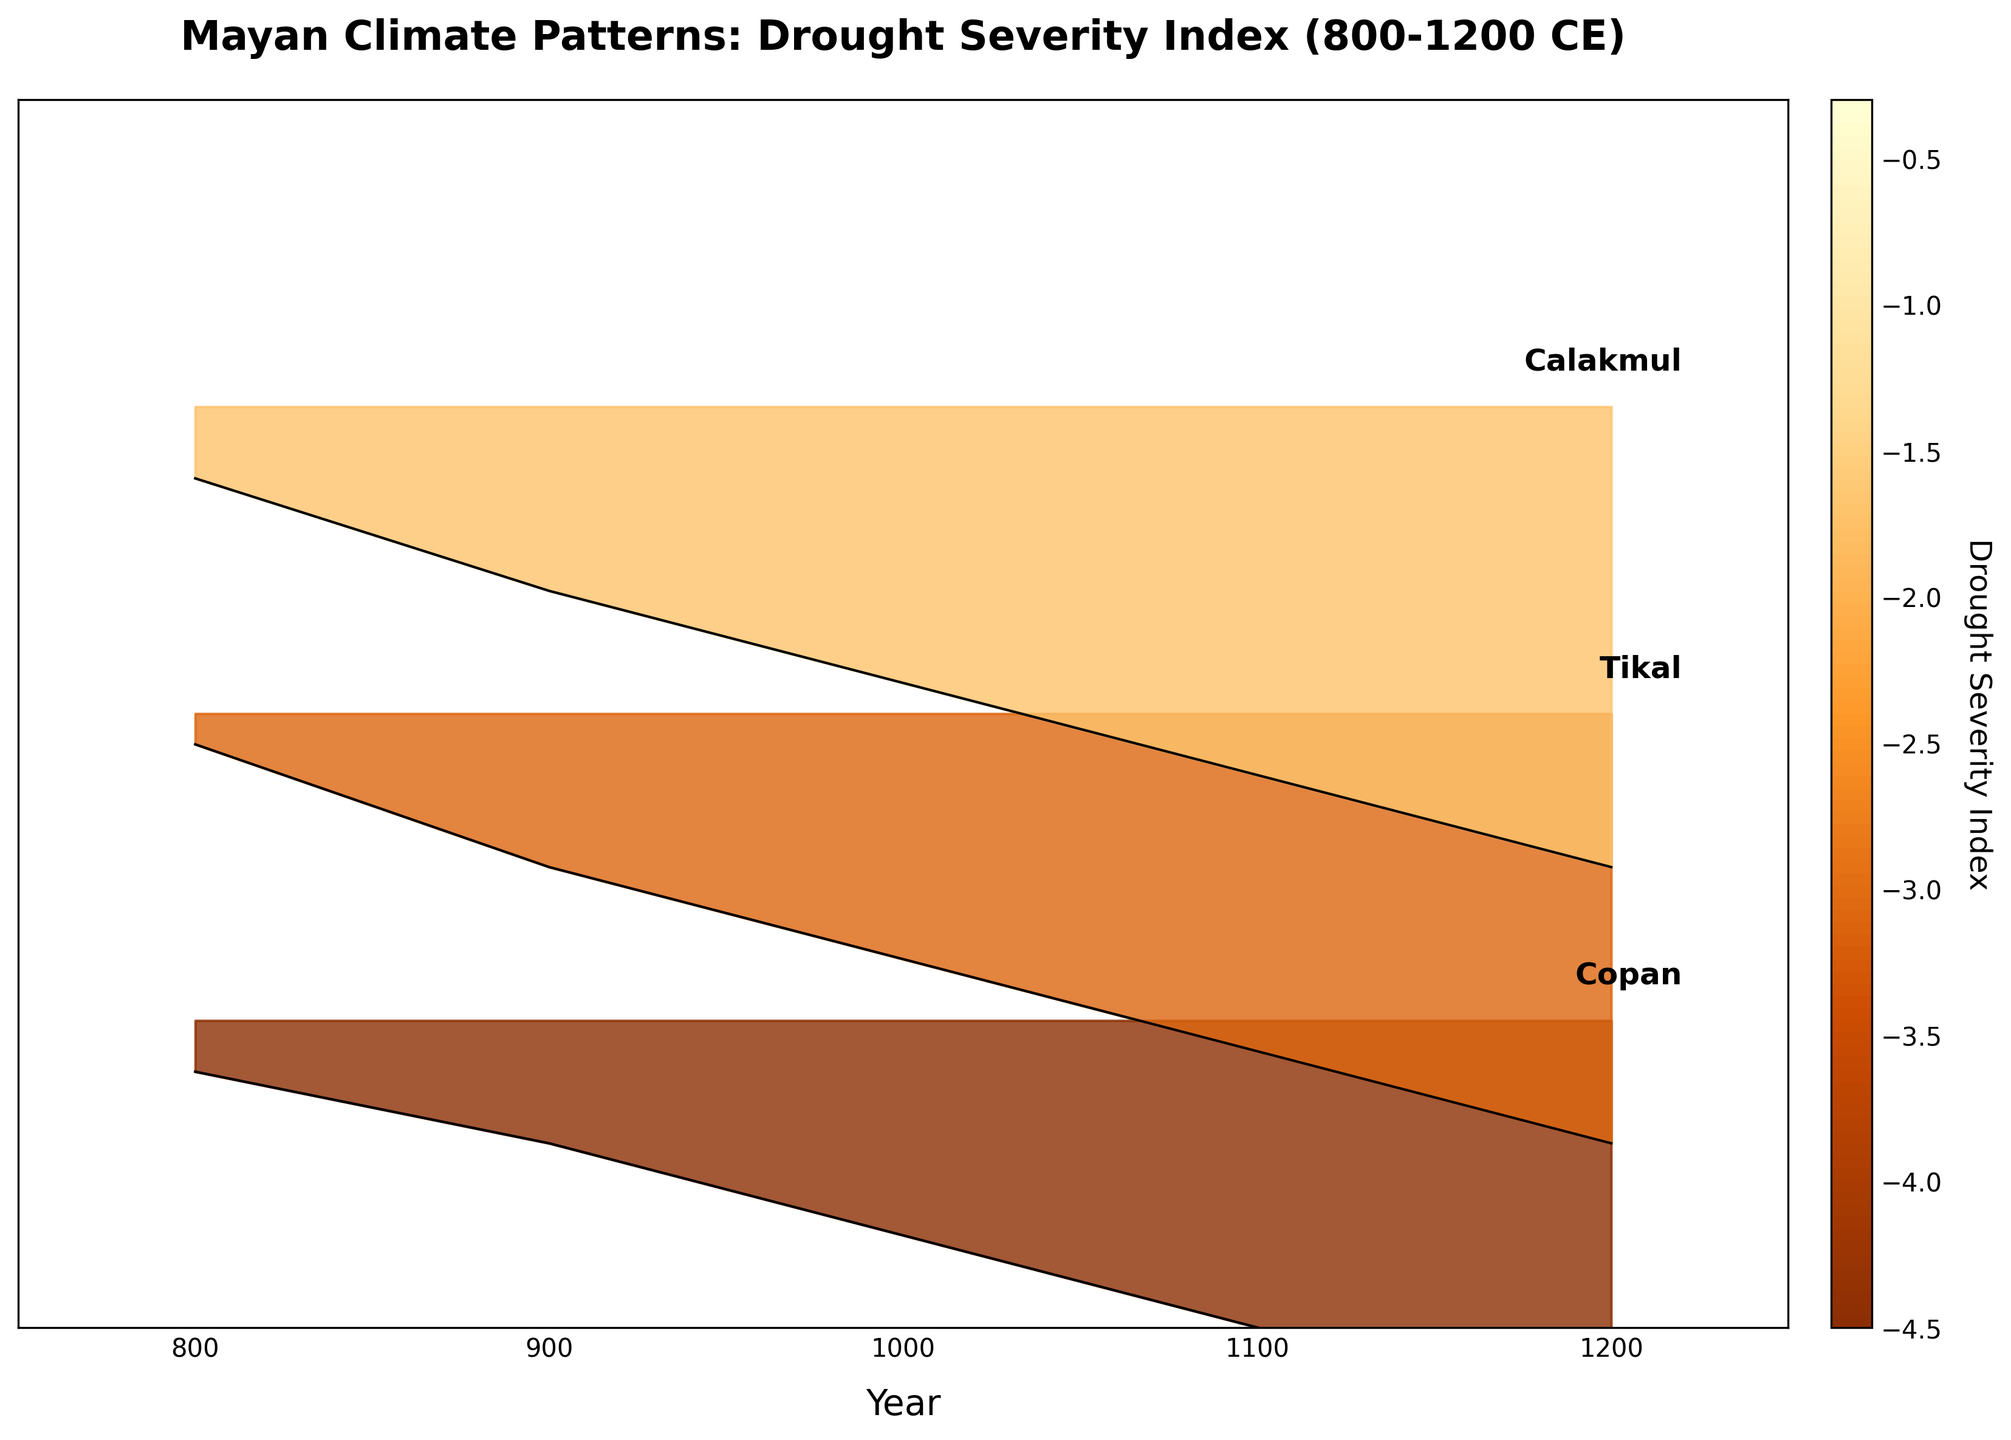What period is covered in the title of the plot? The title of the plot specifies the years 800-1200 CE
Answer: 800-1200 CE How many regions are represented in the plot? The figure labels three regions on the right side of the plot: Copan, Tikal, and Calakmul
Answer: 3 What year shows the highest drought severity index for Copan? The highest drought severity index line for Copan is at the year 1200 CE
Answer: 1200 CE Between which years did Tikal experience a noticeable increase in drought severity? Tikal shows a noticeable drought severity index increase from 800 CE with -0.3 to 1200 CE with -4.2
Answer: 800-1200 CE Which region had the least severe drought index around the year 1000 CE? Around the year 1000 CE, Copan has a value of -2.1, Tikal has -2.4, and Calakmul has -2.7. Copan has the least severe index value
Answer: Copan Compare the trend in the drought severity index for Calakmul between 900 CE and 1200 CE. From 900 CE to 1200 CE, the drought severity index for Calakmul starts at around -1.8 and steadily decreases to -4.5
Answer: steadily decreases How does the drought severity index for each region change from 800 CE to 1100 CE? From 800 CE to 1100 CE, Copan's drought index goes from -0.5 to -3.0, Tikal's from -0.3 to -3.3, and Calakmul's from -0.7 to -3.6, showing a consistent increase in drought severity
Answer: consistent increase Which year shows the most significant difference in drought severity index between Tikal and Calakmul? The year 900 CE shows Tikal at -1.5 and Calakmul at -1.8, with a difference of 0.3, which is more significant compared to other years
Answer: 900 CE What climatic pattern can be inferred from the ridgeline plot concerning Mayan civilization collapse? The ridgeline plot shows an increasing drought severity index across all regions from 800 CE to 1200 CE, suggesting worsening climatic conditions that may have impacted the Mayan civilization collapse
Answer: worsening climatic conditions 